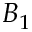<formula> <loc_0><loc_0><loc_500><loc_500>B _ { 1 }</formula> 